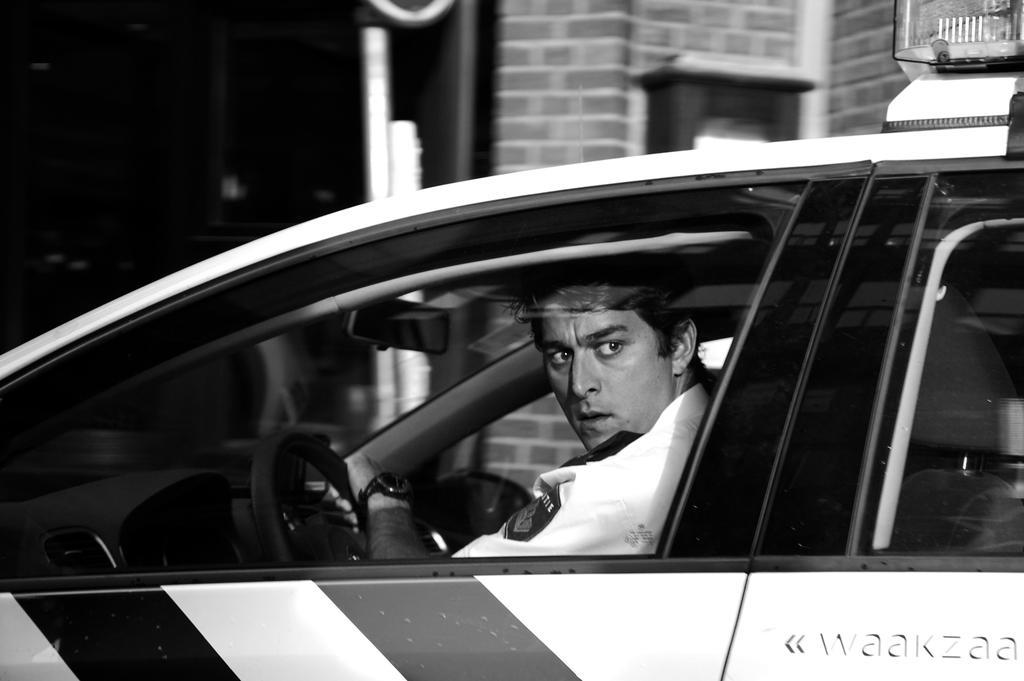Describe this image in one or two sentences. In this image i can see a man sitting in a car, at the back ground i can see a building and a pole. 